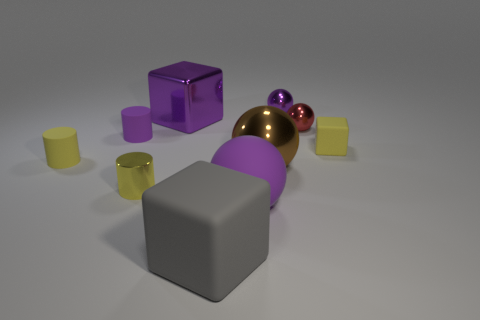Subtract all large matte blocks. How many blocks are left? 2 Subtract 1 spheres. How many spheres are left? 3 Subtract all blocks. How many objects are left? 7 Add 2 matte blocks. How many matte blocks are left? 4 Add 1 tiny yellow blocks. How many tiny yellow blocks exist? 2 Subtract all purple balls. How many balls are left? 2 Subtract 1 purple blocks. How many objects are left? 9 Subtract all brown spheres. Subtract all cyan cubes. How many spheres are left? 3 Subtract all cyan cylinders. How many red balls are left? 1 Subtract all tiny red things. Subtract all gray blocks. How many objects are left? 8 